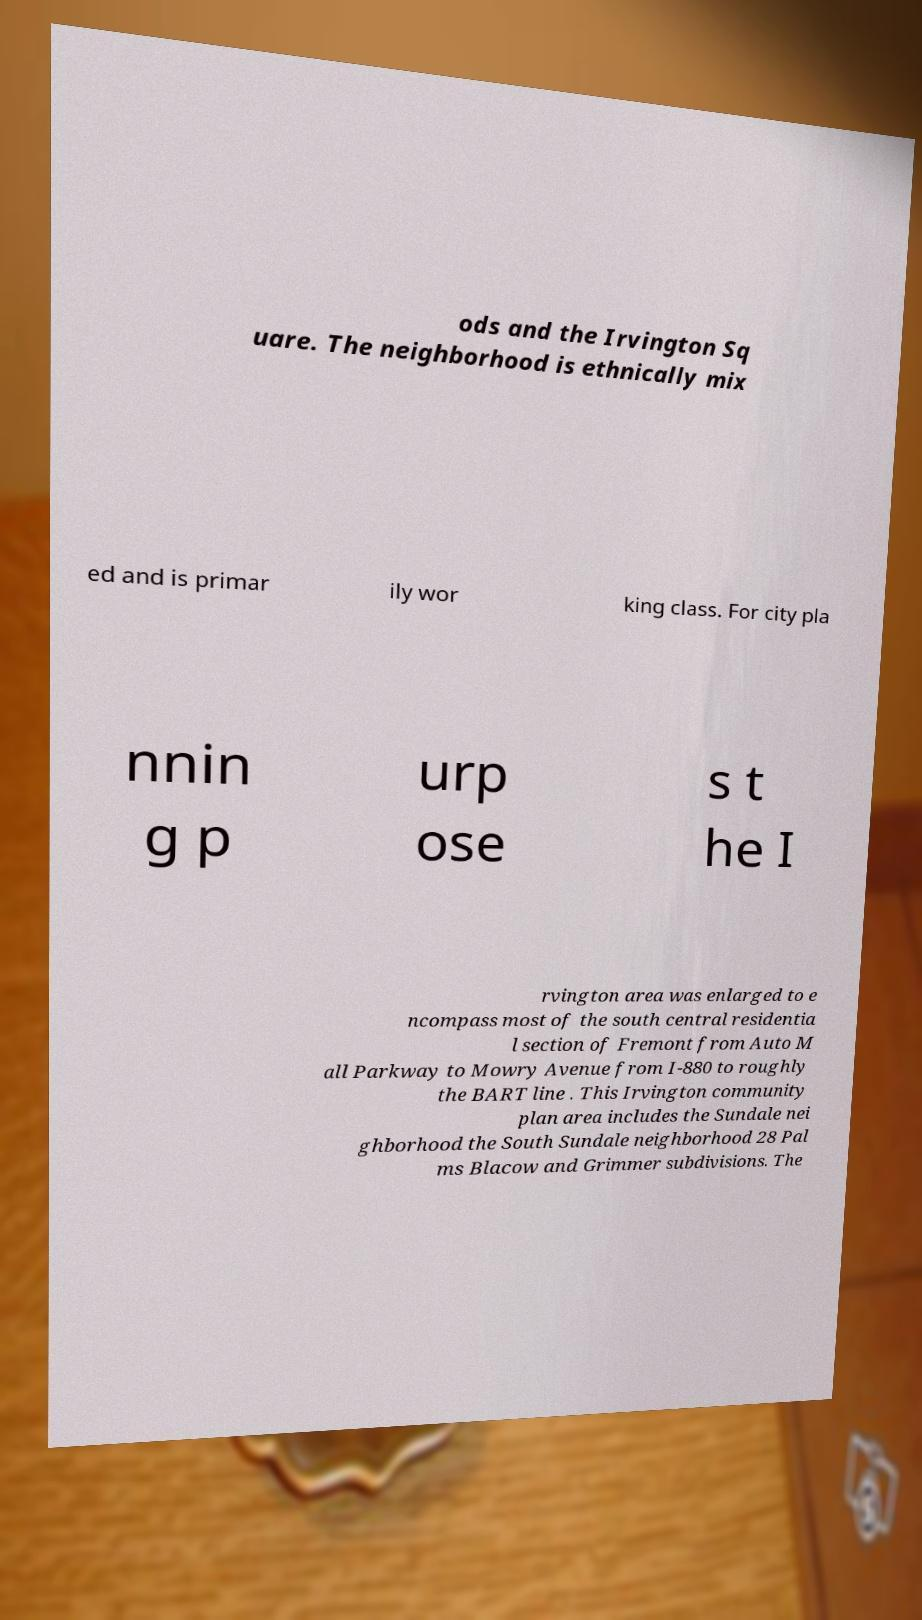Can you accurately transcribe the text from the provided image for me? ods and the Irvington Sq uare. The neighborhood is ethnically mix ed and is primar ily wor king class. For city pla nnin g p urp ose s t he I rvington area was enlarged to e ncompass most of the south central residentia l section of Fremont from Auto M all Parkway to Mowry Avenue from I-880 to roughly the BART line . This Irvington community plan area includes the Sundale nei ghborhood the South Sundale neighborhood 28 Pal ms Blacow and Grimmer subdivisions. The 